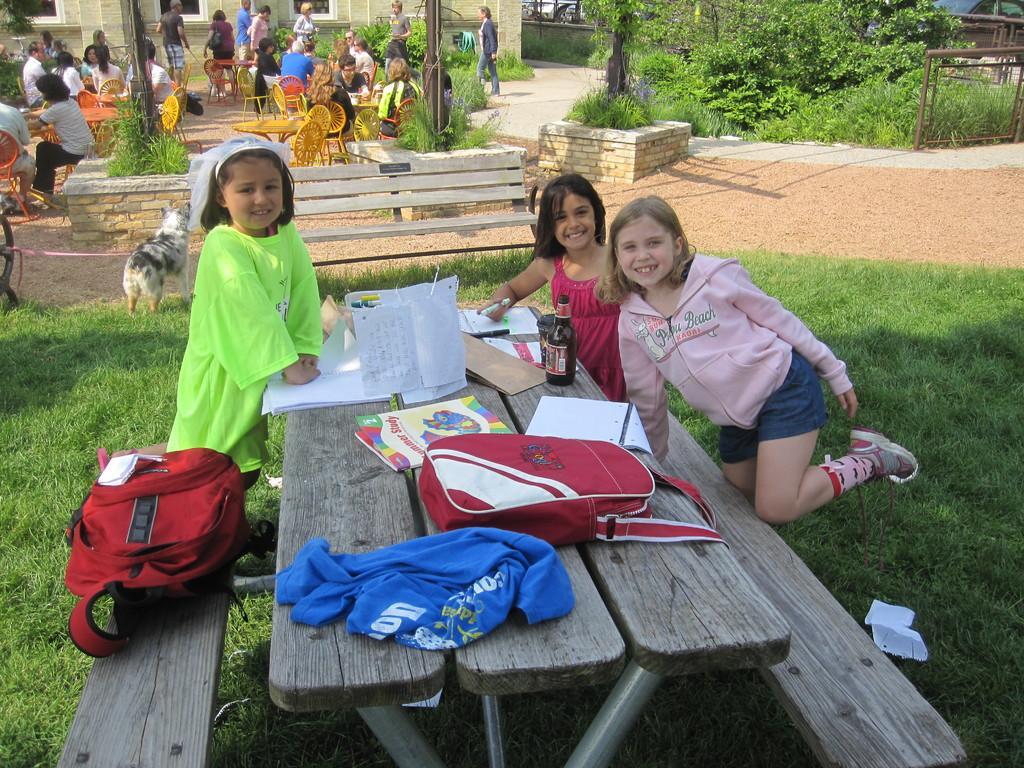Can you describe this image briefly? There are three girls near bench in a lawn. There is a bag on the bench. And another bag on the table. A blue colored cloth. And in the background there is dog. We can observe some plants here on the right side. There are some people sitting and walking in the background. 